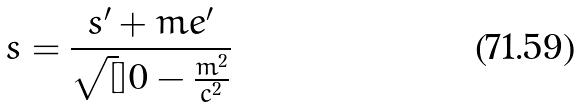Convert formula to latex. <formula><loc_0><loc_0><loc_500><loc_500>s = \frac { s ^ { \prime } + m e ^ { \prime } } { \sqrt { [ } ] { 0 - \frac { m ^ { 2 } } { c ^ { 2 } } } }</formula> 